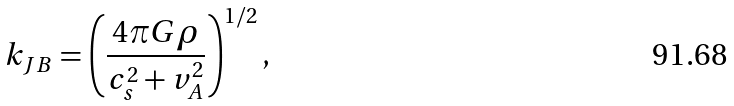<formula> <loc_0><loc_0><loc_500><loc_500>k _ { J B } = \left ( \frac { 4 \pi G \rho } { c _ { s } ^ { 2 } + v _ { A } ^ { 2 } } \right ) ^ { 1 / 2 } ,</formula> 